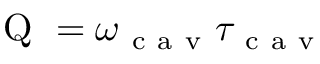<formula> <loc_0><loc_0><loc_500><loc_500>Q = \omega _ { c a v } \tau _ { c a v }</formula> 